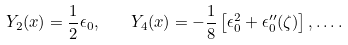Convert formula to latex. <formula><loc_0><loc_0><loc_500><loc_500>Y _ { 2 } ( x ) = { \frac { 1 } { 2 } } \epsilon _ { 0 } , \quad Y _ { 4 } ( x ) = - { \frac { 1 } { 8 } } \left [ \epsilon _ { 0 } ^ { 2 } + \epsilon _ { 0 } ^ { \prime \prime } ( \zeta ) \right ] , \dots .</formula> 